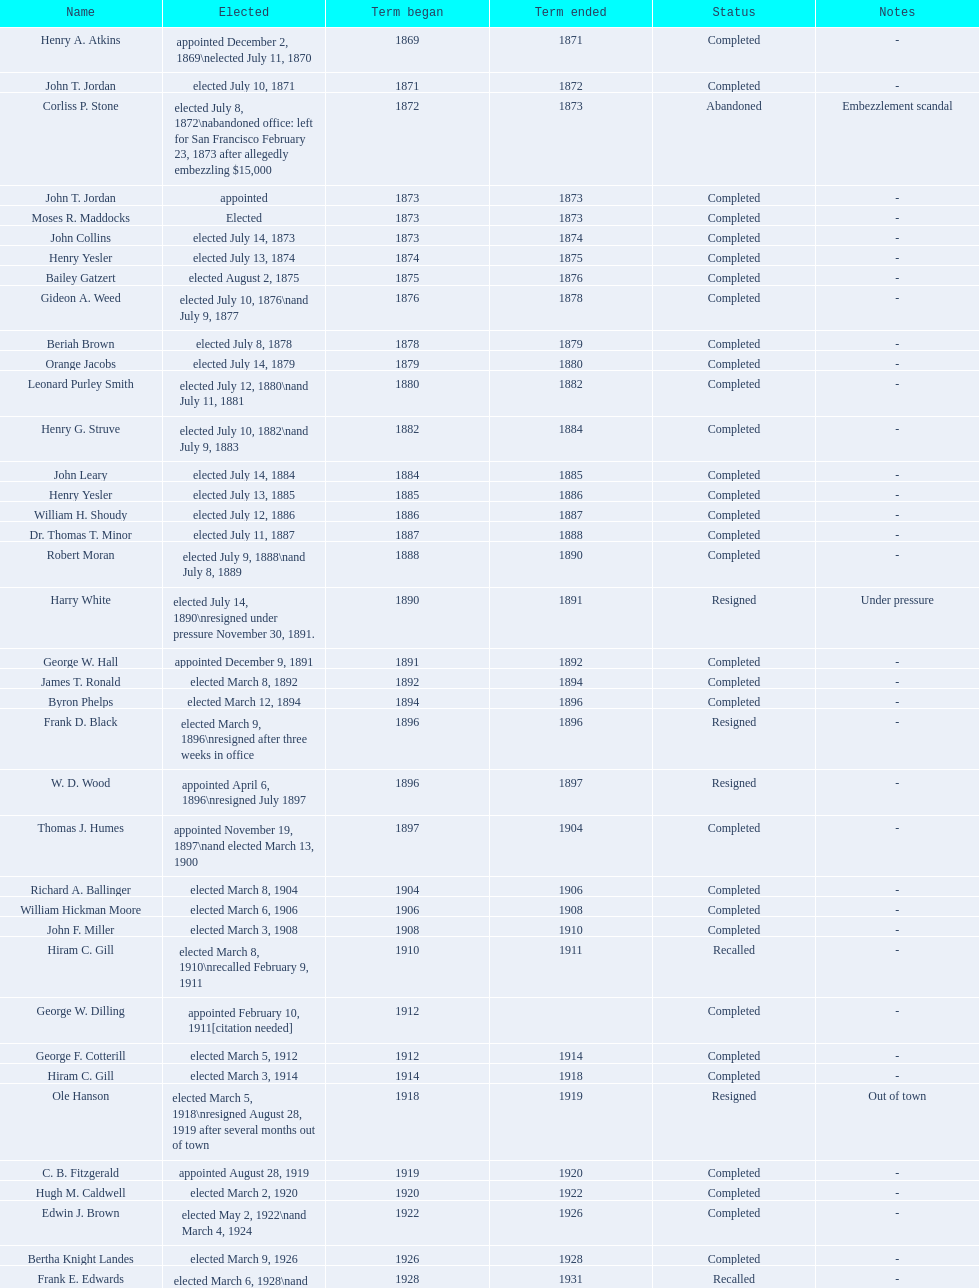How many women have been elected mayor of seattle, washington? 1. 